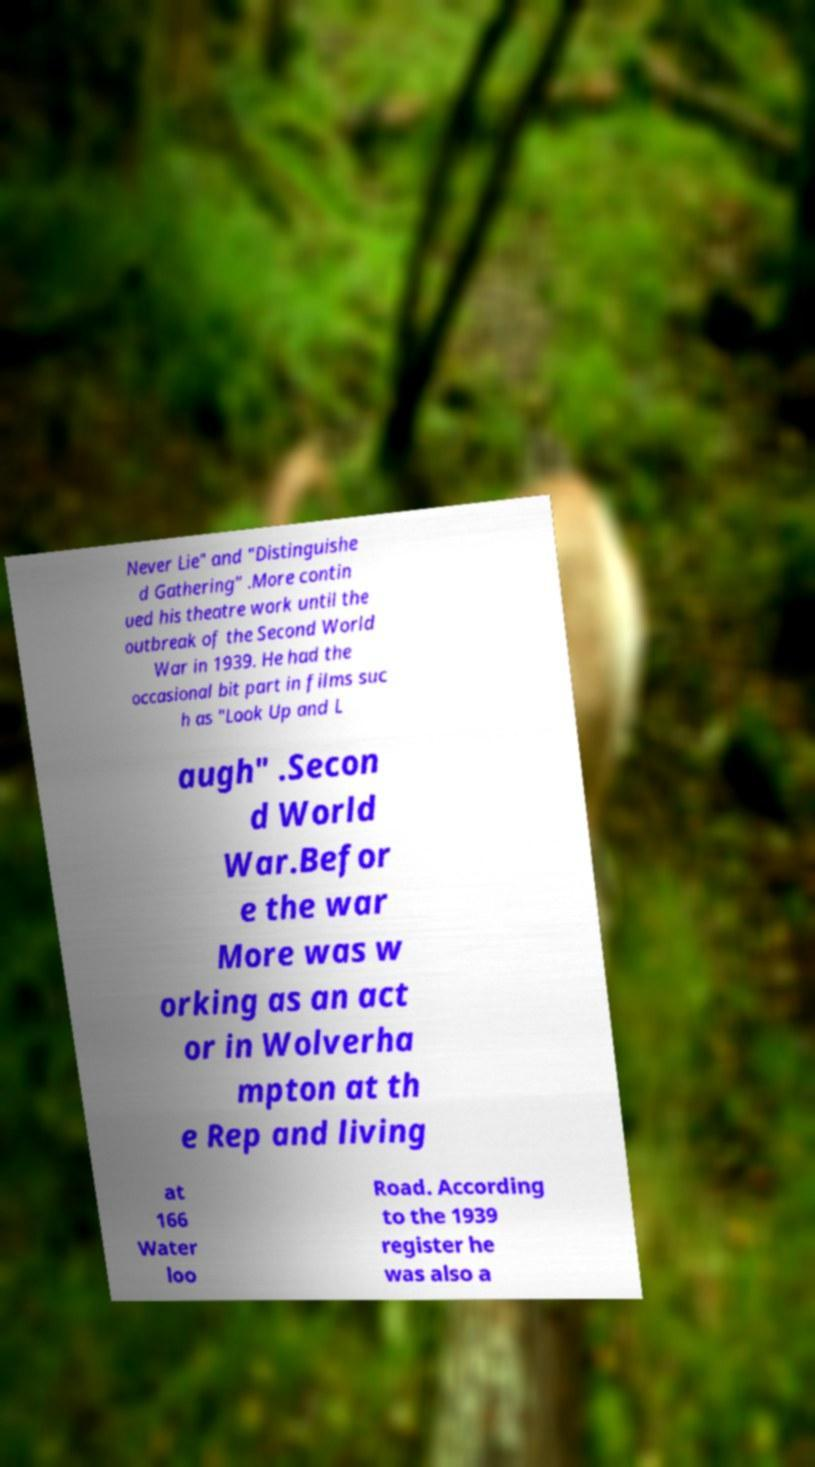Can you accurately transcribe the text from the provided image for me? Never Lie" and "Distinguishe d Gathering" .More contin ued his theatre work until the outbreak of the Second World War in 1939. He had the occasional bit part in films suc h as "Look Up and L augh" .Secon d World War.Befor e the war More was w orking as an act or in Wolverha mpton at th e Rep and living at 166 Water loo Road. According to the 1939 register he was also a 